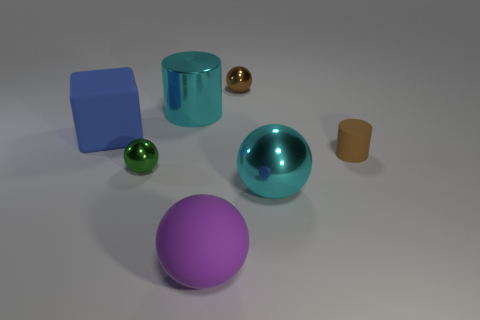Add 1 big matte objects. How many objects exist? 8 Subtract all big rubber balls. How many balls are left? 3 Subtract 1 balls. How many balls are left? 3 Subtract all brown cylinders. How many cylinders are left? 1 Subtract all cubes. How many objects are left? 6 Subtract all gray balls. How many cyan cylinders are left? 1 Subtract all big rubber cylinders. Subtract all small green metal objects. How many objects are left? 6 Add 1 cyan shiny cylinders. How many cyan shiny cylinders are left? 2 Add 4 tiny brown balls. How many tiny brown balls exist? 5 Subtract 0 yellow cubes. How many objects are left? 7 